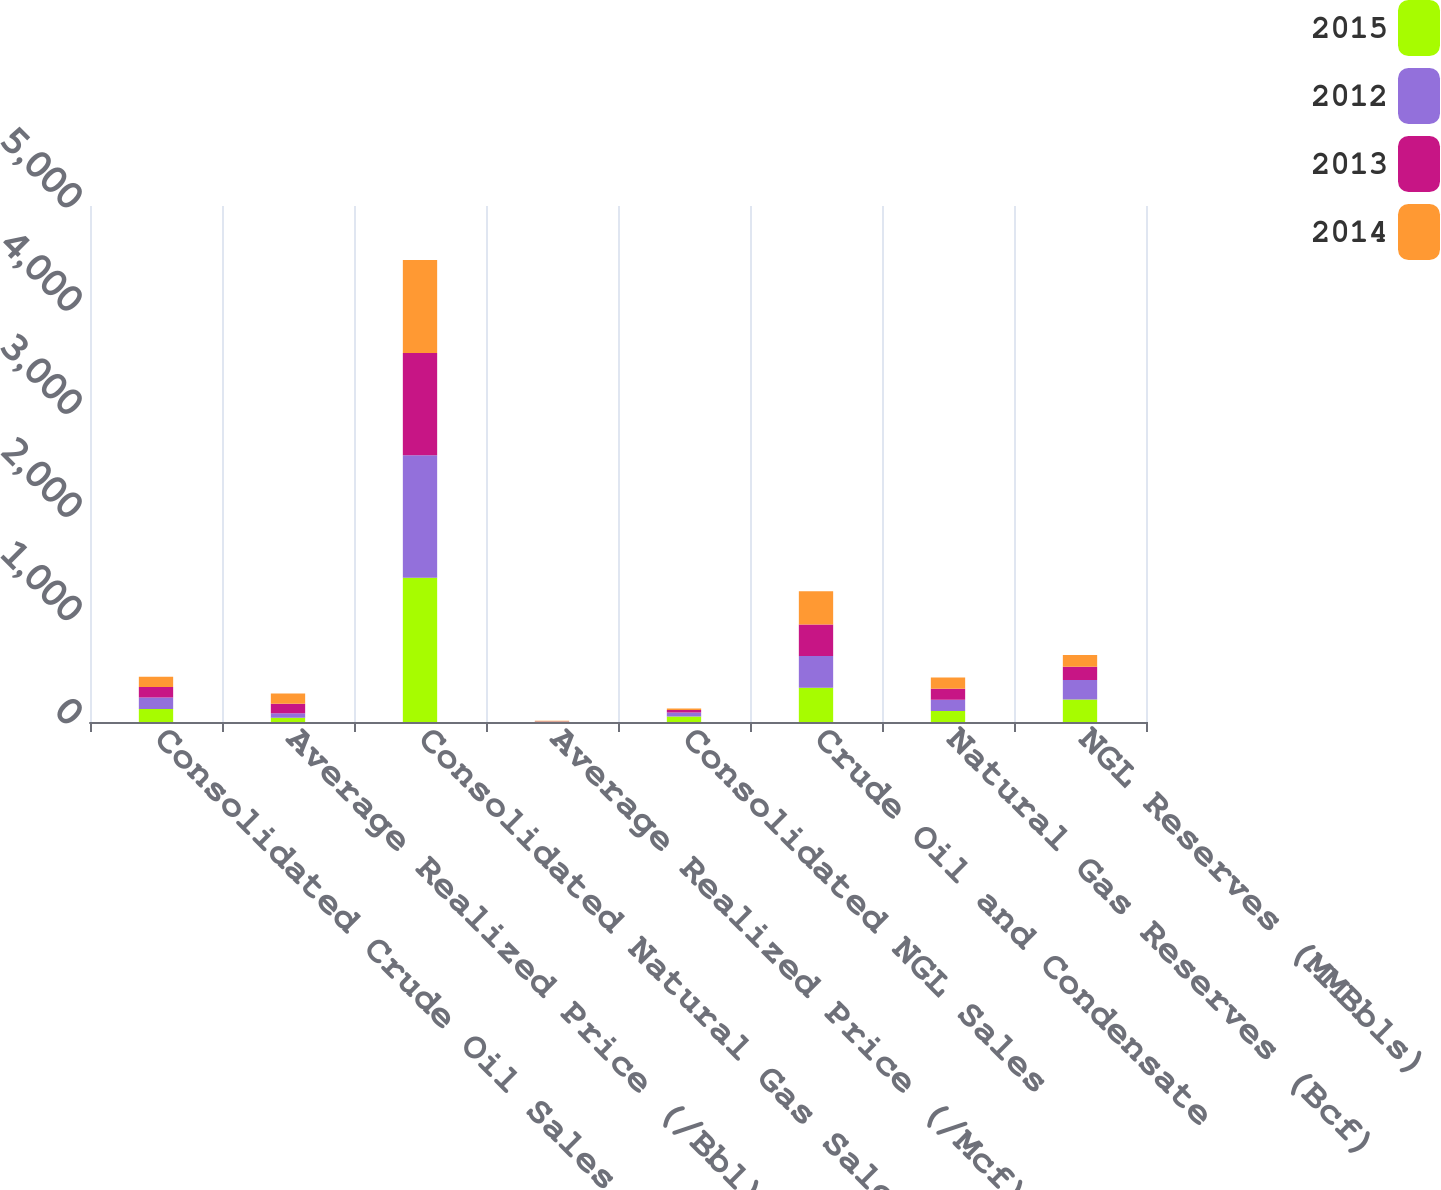<chart> <loc_0><loc_0><loc_500><loc_500><stacked_bar_chart><ecel><fcel>Consolidated Crude Oil Sales<fcel>Average Realized Price (/Bbl)<fcel>Consolidated Natural Gas Sales<fcel>Average Realized Price (/Mcf)<fcel>Consolidated NGL Sales<fcel>Crude Oil and Condensate<fcel>Natural Gas Reserves (Bcf)<fcel>NGL Reserves (MMBbls)<nl><fcel>2015<fcel>125<fcel>40.39<fcel>1397<fcel>2.42<fcel>54<fcel>333<fcel>107.5<fcel>219<nl><fcel>2012<fcel>112<fcel>45<fcel>1187<fcel>2.44<fcel>39<fcel>307<fcel>107.5<fcel>189<nl><fcel>2013<fcel>103<fcel>91.58<fcel>992<fcel>3.38<fcel>23<fcel>304<fcel>107.5<fcel>128<nl><fcel>2014<fcel>99<fcel>100.29<fcel>901<fcel>2.97<fcel>16<fcel>322<fcel>107.5<fcel>113<nl></chart> 